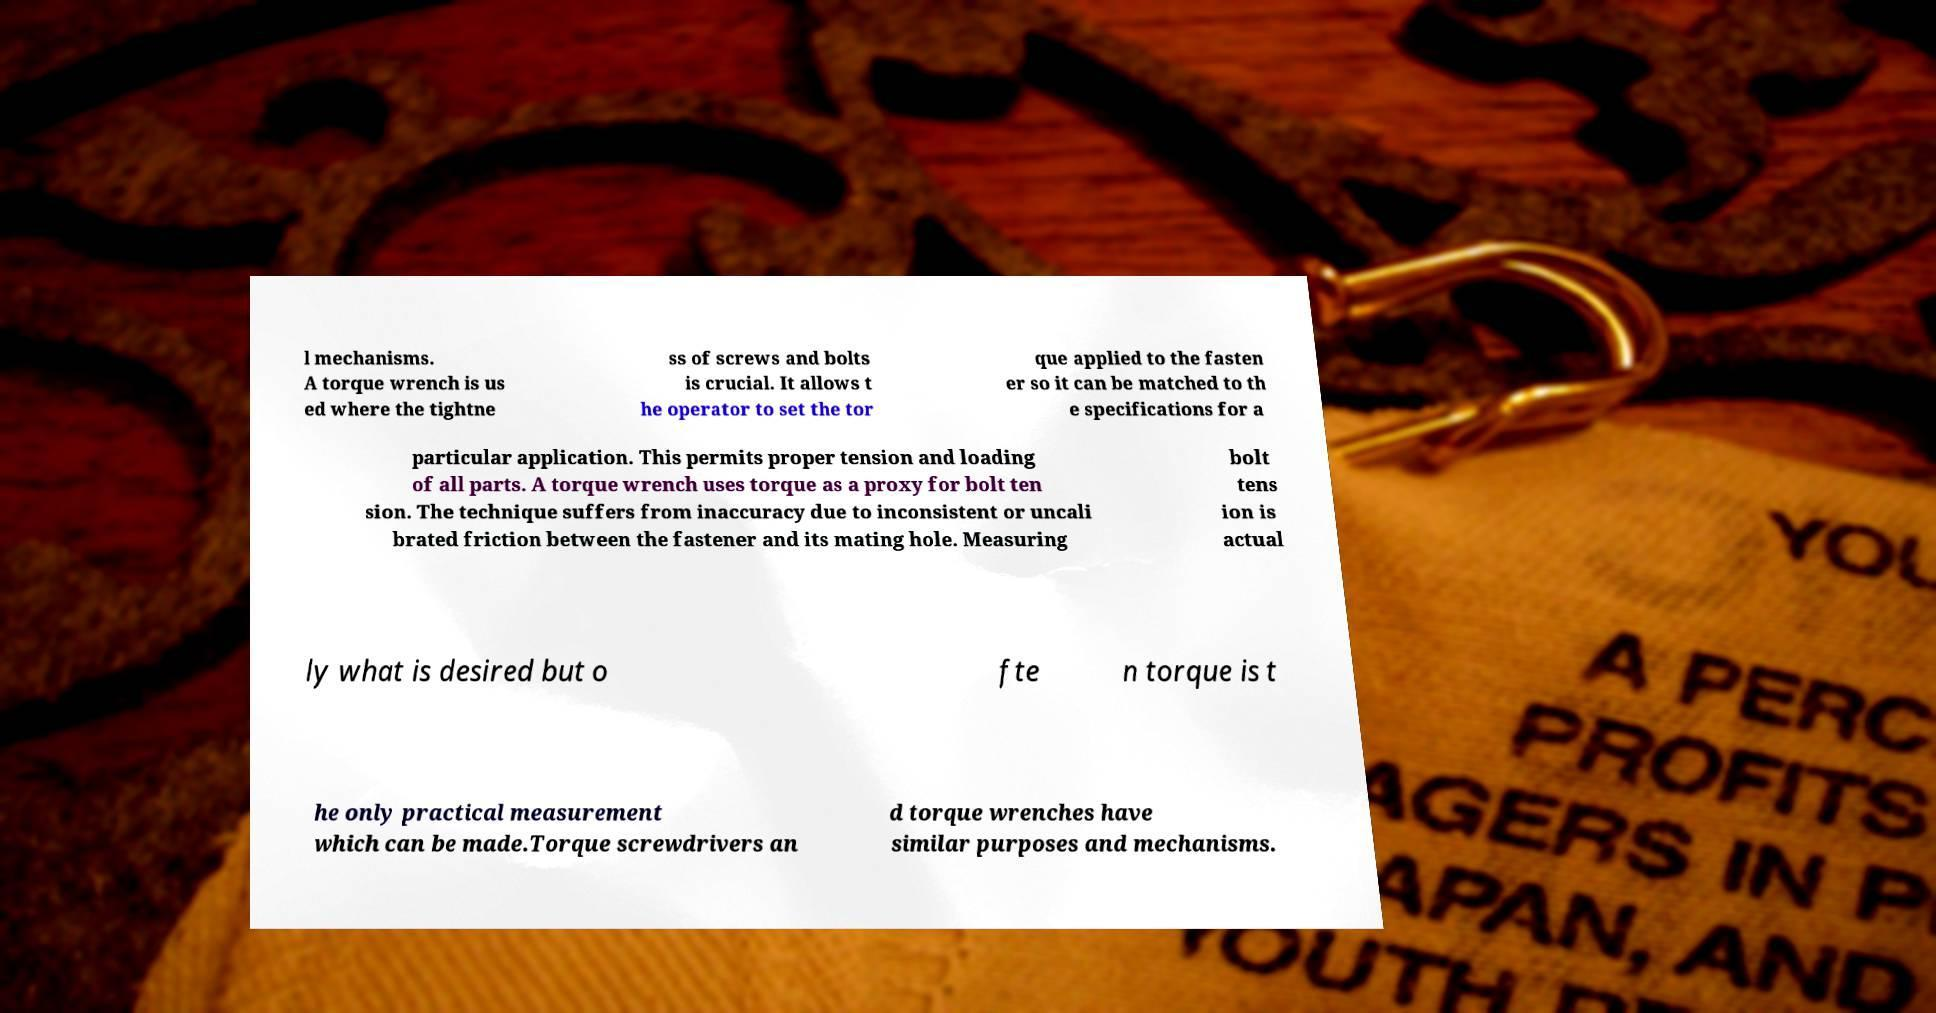Please identify and transcribe the text found in this image. l mechanisms. A torque wrench is us ed where the tightne ss of screws and bolts is crucial. It allows t he operator to set the tor que applied to the fasten er so it can be matched to th e specifications for a particular application. This permits proper tension and loading of all parts. A torque wrench uses torque as a proxy for bolt ten sion. The technique suffers from inaccuracy due to inconsistent or uncali brated friction between the fastener and its mating hole. Measuring bolt tens ion is actual ly what is desired but o fte n torque is t he only practical measurement which can be made.Torque screwdrivers an d torque wrenches have similar purposes and mechanisms. 